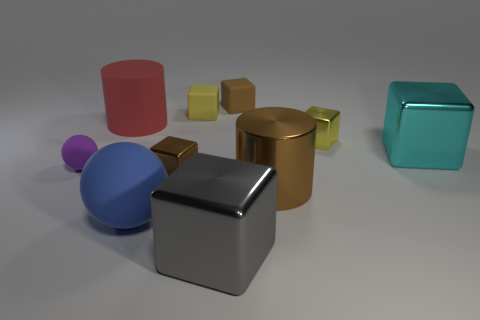Subtract all tiny yellow cubes. How many cubes are left? 4 Subtract all gray blocks. How many blocks are left? 5 Subtract 1 cylinders. How many cylinders are left? 1 Add 8 brown metal balls. How many brown metal balls exist? 8 Subtract 0 cyan cylinders. How many objects are left? 10 Subtract all blocks. How many objects are left? 4 Subtract all green cylinders. Subtract all cyan balls. How many cylinders are left? 2 Subtract all purple cylinders. How many yellow blocks are left? 2 Subtract all small brown blocks. Subtract all metal cylinders. How many objects are left? 7 Add 7 gray metal cubes. How many gray metal cubes are left? 8 